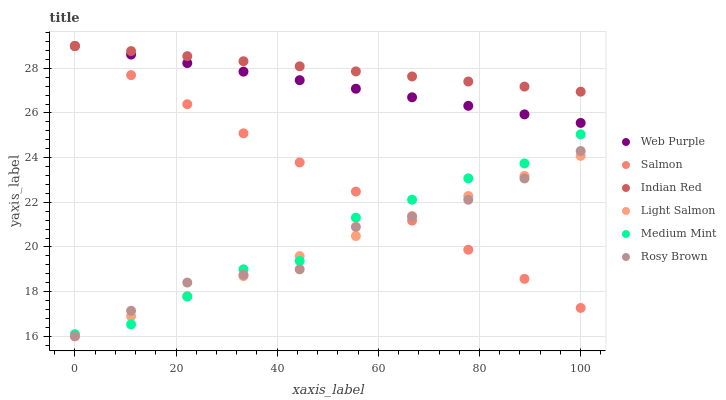Does Light Salmon have the minimum area under the curve?
Answer yes or no. Yes. Does Indian Red have the maximum area under the curve?
Answer yes or no. Yes. Does Rosy Brown have the minimum area under the curve?
Answer yes or no. No. Does Rosy Brown have the maximum area under the curve?
Answer yes or no. No. Is Web Purple the smoothest?
Answer yes or no. Yes. Is Medium Mint the roughest?
Answer yes or no. Yes. Is Light Salmon the smoothest?
Answer yes or no. No. Is Light Salmon the roughest?
Answer yes or no. No. Does Light Salmon have the lowest value?
Answer yes or no. Yes. Does Salmon have the lowest value?
Answer yes or no. No. Does Indian Red have the highest value?
Answer yes or no. Yes. Does Rosy Brown have the highest value?
Answer yes or no. No. Is Light Salmon less than Indian Red?
Answer yes or no. Yes. Is Indian Red greater than Rosy Brown?
Answer yes or no. Yes. Does Rosy Brown intersect Light Salmon?
Answer yes or no. Yes. Is Rosy Brown less than Light Salmon?
Answer yes or no. No. Is Rosy Brown greater than Light Salmon?
Answer yes or no. No. Does Light Salmon intersect Indian Red?
Answer yes or no. No. 